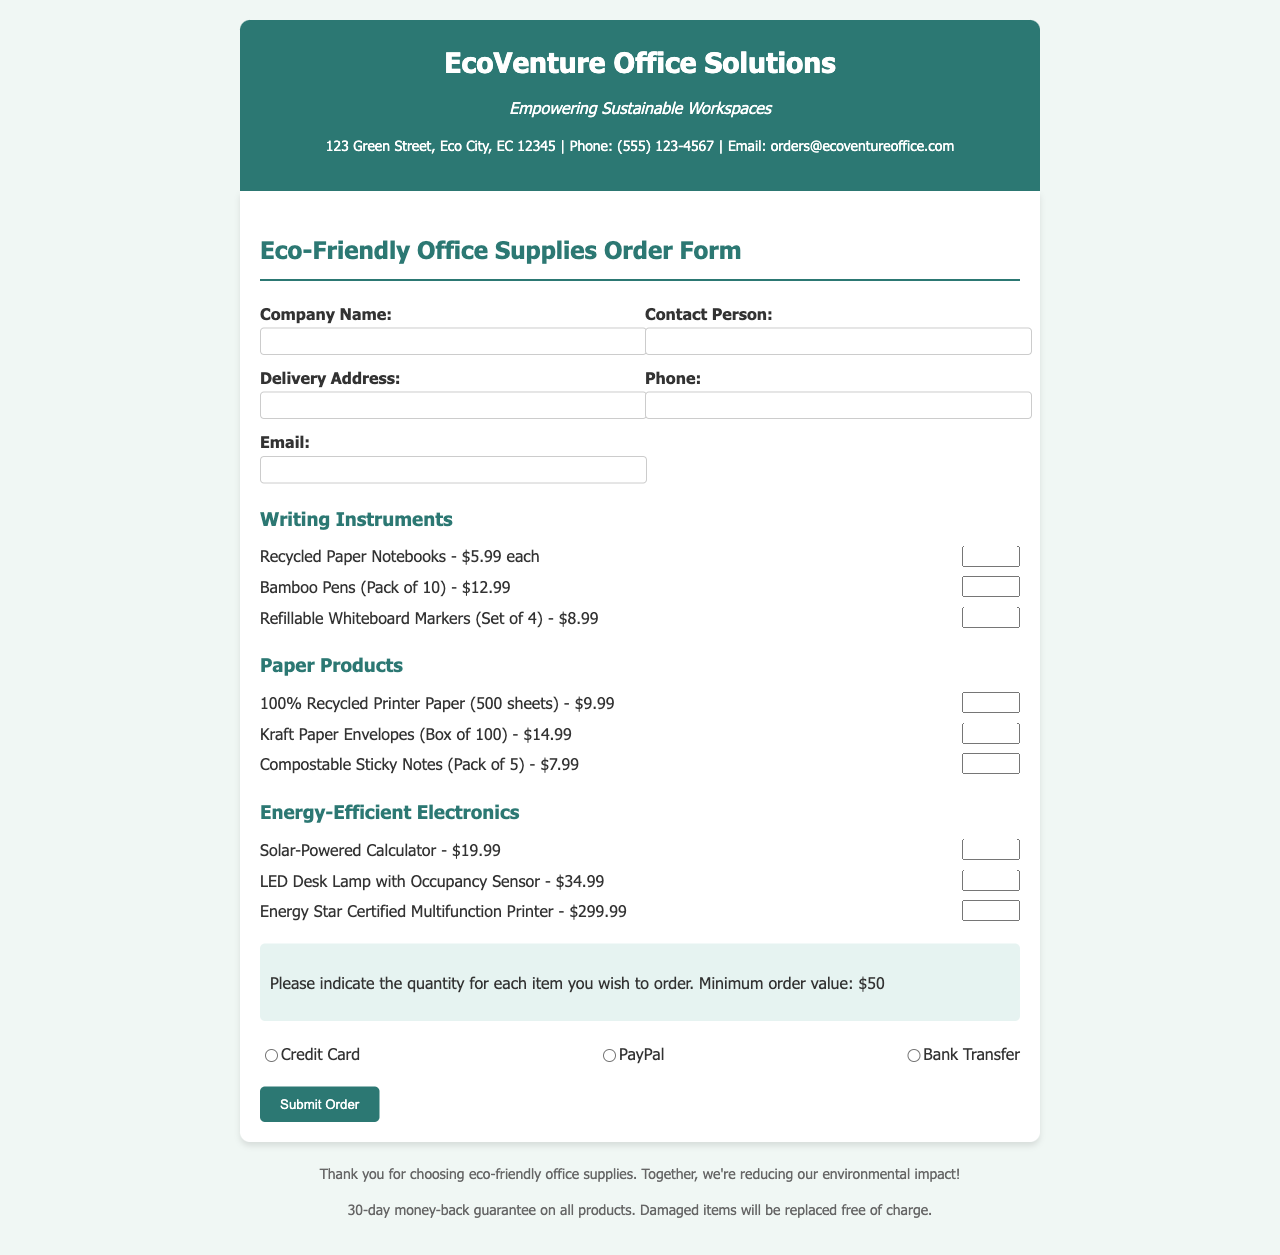What is the company name? The company name is shown in the document header under the title.
Answer: EcoVenture Office Solutions What is the address for order delivery? The delivery address is a required field in the customer details section.
Answer: 123 Green Street, Eco City, EC 12345 What product is priced at $9.99? The product price can be found under the Paper Products section.
Answer: 100% Recycled Printer Paper (500 sheets) What is the minimum order value? The minimum order value is mentioned in the order instructions.
Answer: $50 How many writing instruments are listed in the document? The writing instruments listed can be counted under the Writing Instruments product category.
Answer: 3 What payment methods are available? The payment options are listed in the payment section of the form.
Answer: Credit Card, PayPal, Bank Transfer Which product has a name that includes "energy-efficient"? The product names can be found in the Energy-Efficient Electronics category.
Answer: LED Desk Lamp with Occupancy Sensor What is the contact phone number for orders? The contact information is provided in the header of the document.
Answer: (555) 123-4567 What type of guarantee is offered on all products? The type of guarantee is mentioned in the footer of the document.
Answer: 30-day money-back guarantee 